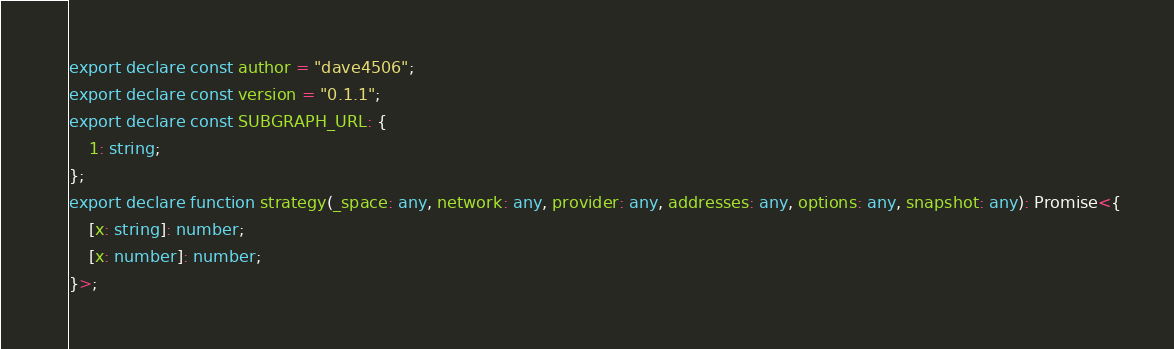<code> <loc_0><loc_0><loc_500><loc_500><_TypeScript_>export declare const author = "dave4506";
export declare const version = "0.1.1";
export declare const SUBGRAPH_URL: {
    1: string;
};
export declare function strategy(_space: any, network: any, provider: any, addresses: any, options: any, snapshot: any): Promise<{
    [x: string]: number;
    [x: number]: number;
}>;
</code> 